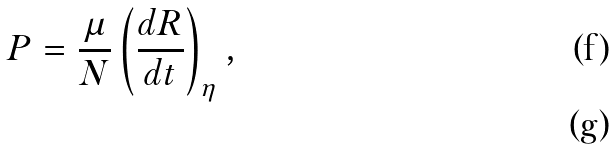<formula> <loc_0><loc_0><loc_500><loc_500>P = \frac { \mu } { N } \left ( \frac { d R } { d t } \right ) _ { \eta } , \\</formula> 